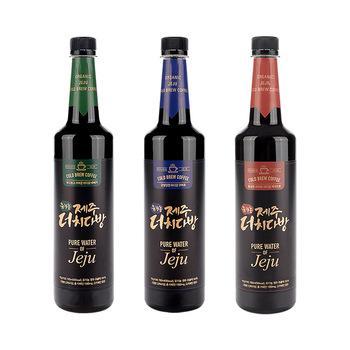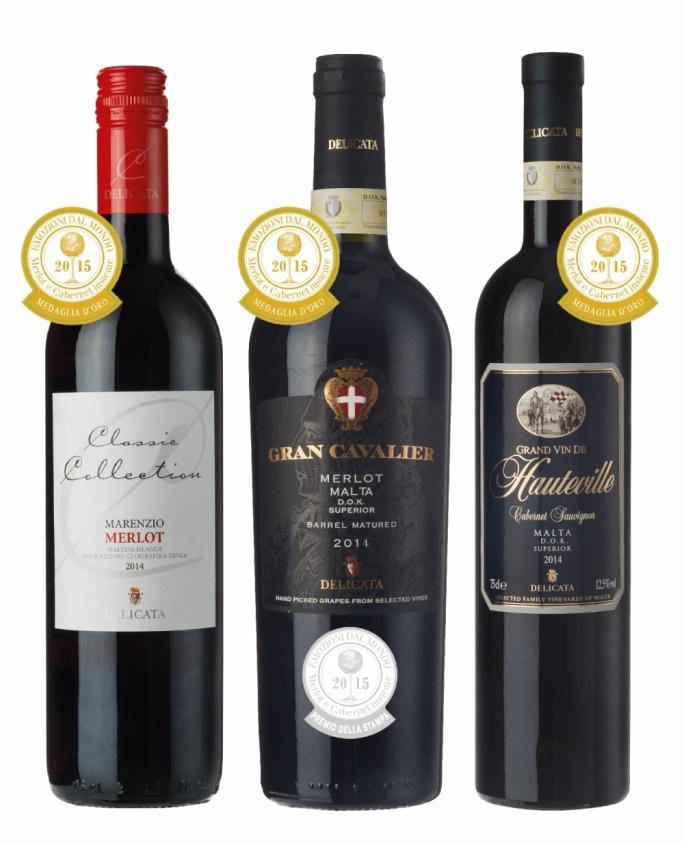The first image is the image on the left, the second image is the image on the right. Analyze the images presented: Is the assertion "Exactly six bottles of wine are capped and have labels, and are divided into two groups, at least two bottles in each group." valid? Answer yes or no. Yes. The first image is the image on the left, the second image is the image on the right. Given the left and right images, does the statement "There are no more than three wine bottles in the left image." hold true? Answer yes or no. Yes. 